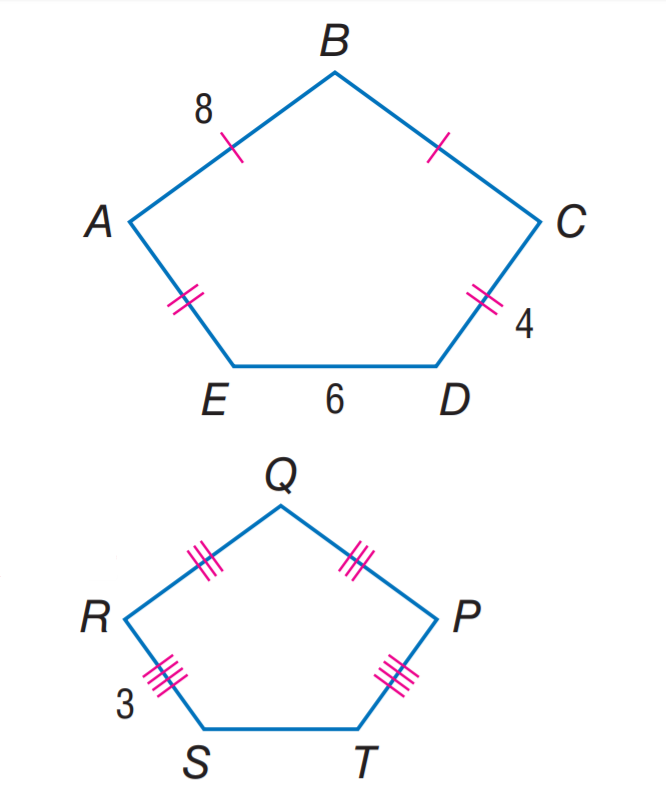Question: If A B C D E \sim P Q R S T, find the scale factor of A B C D E to P Q R S T.
Choices:
A. \frac { 4 } { 3 }
B. 2
C. \frac { 8 } { 3 }
D. 4
Answer with the letter. Answer: A Question: If A B C D E \sim P Q R S T, find the perimeter of A B C D E.
Choices:
A. 22.5
B. 27.5
C. 30
D. 35
Answer with the letter. Answer: C Question: If A B C D E \sim P Q R S T, find the perimeter of P Q R S T.
Choices:
A. 22.5
B. 25
C. 27.5
D. 30
Answer with the letter. Answer: A 